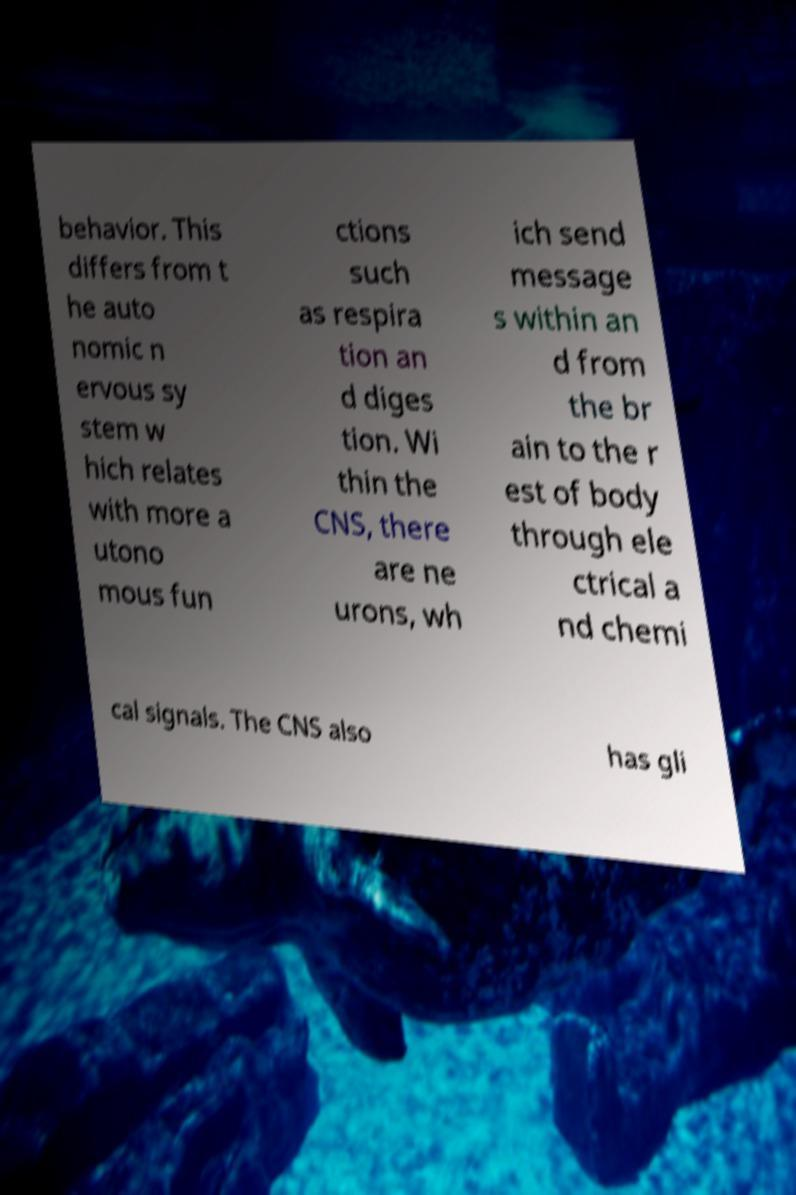Please read and relay the text visible in this image. What does it say? behavior. This differs from t he auto nomic n ervous sy stem w hich relates with more a utono mous fun ctions such as respira tion an d diges tion. Wi thin the CNS, there are ne urons, wh ich send message s within an d from the br ain to the r est of body through ele ctrical a nd chemi cal signals. The CNS also has gli 